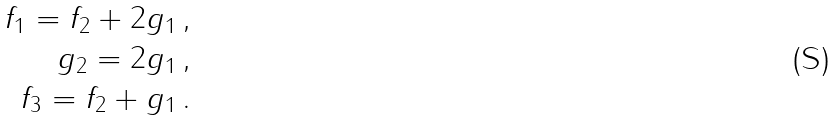<formula> <loc_0><loc_0><loc_500><loc_500>f _ { 1 } = f _ { 2 } + 2 g _ { 1 } \, , \\ g _ { 2 } = 2 g _ { 1 } \, , \\ f _ { 3 } = f _ { 2 } + g _ { 1 } \, .</formula> 